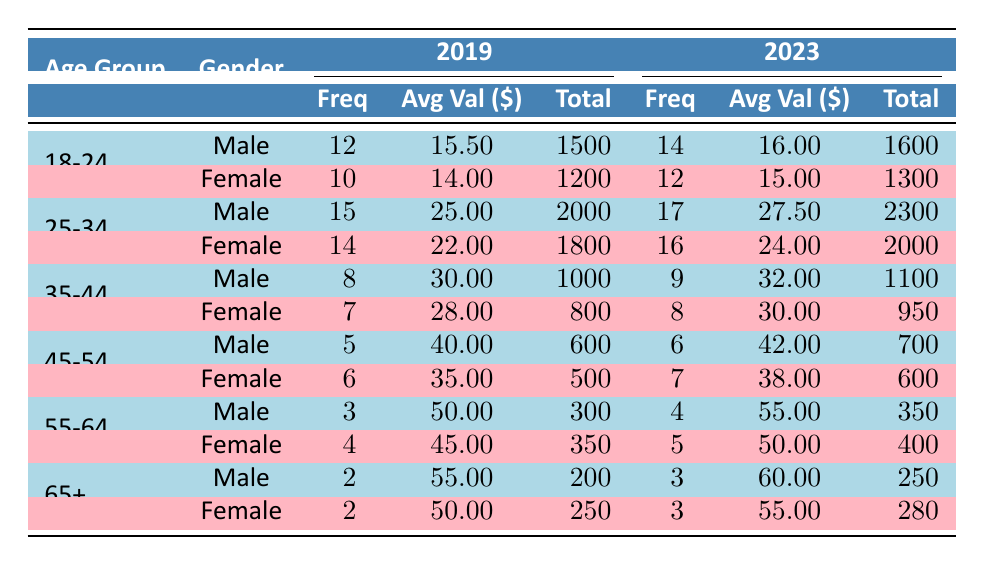What was the total value of purchases for male customers aged 25-34 in 2023? For male customers aged 25-34 in 2023, the total purchases are listed as 2300.
Answer: 2300 How much did female customers aged 55-64 spend per purchase on average in 2019? The average purchase value for female customers aged 55-64 in 2019 is shown as 45.00.
Answer: 45.00 Did the purchase frequency for male customers aged 35-44 increase or decrease from 2019 to 2023? In 2019, the purchase frequency was 8, and in 2023 it rose to 9, indicating an increase.
Answer: Increase What is the total number of purchases made by female customers aged 45-54 in 2023? The total purchases made by female customers aged 45-54 in 2023 are listed as 600.
Answer: 600 What is the difference in average purchase value for male customers aged 65 and older between 2019 and 2023? The average purchase value for males aged 65+ in 2019 is 55.00, and in 2023 it is 60.00. The difference is 60.00 - 55.00 = 5.00.
Answer: 5.00 Which demographic had the highest purchase frequency in 2023? Male customers aged 25-34 had the highest purchase frequency in 2023 with 17 purchases.
Answer: Male 25-34 What was the total spending of female customers aged 18-24 across both years? For female customers aged 18-24, the total in 2019 was 1200, and in 2023 it was 1300. The total spending across both years is 1200 + 1300 = 2500.
Answer: 2500 Is the average purchase value for female customers aged 35-44 higher in 2023 than it was in 2019? The average in 2019 for females aged 35-44 is 28.00 and in 2023 it is 30.00, so yes, it is higher in 2023.
Answer: Yes What is the cumulative purchase frequency for male and female customers aged 55-64 in 2023? In 2023, the purchase frequency for males is 4 and for females is 5. The cumulative frequency is 4 + 5 = 9.
Answer: 9 